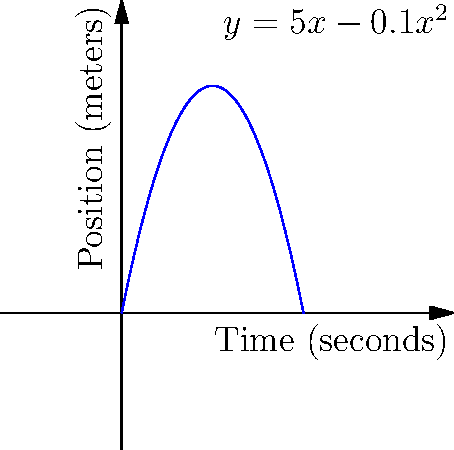Imagine Oleg Blokhin, the legendary Ukrainian footballer, running down the field during a crucial match against Dynamo Moscow in 1986. His position (in meters) as a function of time (in seconds) is given by the equation $y = 5x - 0.1x^2$, where $y$ is his position and $x$ is the time. Using the position-time graph, determine Blokhin's instantaneous velocity at $t = 20$ seconds. To find the instantaneous velocity at $t = 20$ seconds, we need to calculate the derivative of the position function at that point. Here's how we do it:

1) The position function is $y = 5x - 0.1x^2$

2) The velocity function is the derivative of the position function:
   $v(x) = \frac{dy}{dx} = 5 - 0.2x$

3) To find the instantaneous velocity at $t = 20$ seconds, we substitute $x = 20$ into the velocity function:

   $v(20) = 5 - 0.2(20)$
   $v(20) = 5 - 4$
   $v(20) = 1$

4) Therefore, Blokhin's instantaneous velocity at $t = 20$ seconds is 1 meter per second.

5) We can also interpret this graphically: the instantaneous velocity at any point is the slope of the tangent line to the position-time curve at that point. At $t = 20$, we can see that the curve is starting to level off, consistent with a velocity of 1 m/s.
Answer: 1 m/s 